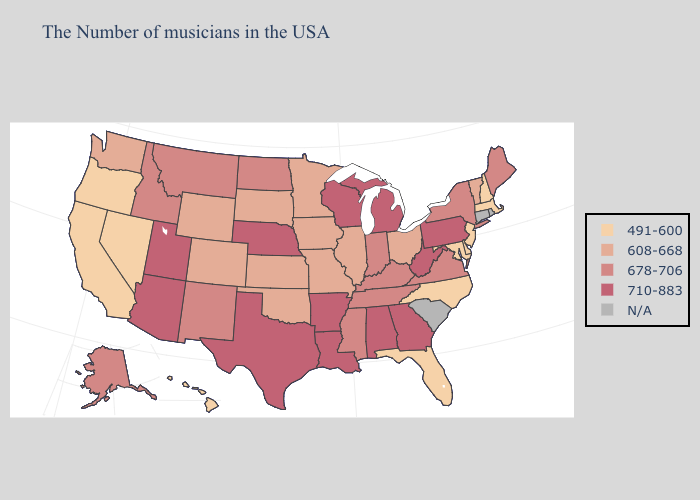How many symbols are there in the legend?
Concise answer only. 5. Which states have the lowest value in the South?
Be succinct. Delaware, Maryland, North Carolina, Florida. What is the highest value in states that border Mississippi?
Write a very short answer. 710-883. Among the states that border Kansas , does Nebraska have the lowest value?
Be succinct. No. Which states hav the highest value in the South?
Quick response, please. West Virginia, Georgia, Alabama, Louisiana, Arkansas, Texas. Among the states that border South Carolina , does North Carolina have the highest value?
Write a very short answer. No. What is the value of New Mexico?
Concise answer only. 678-706. What is the lowest value in the USA?
Keep it brief. 491-600. Does Missouri have the highest value in the MidWest?
Keep it brief. No. What is the highest value in the USA?
Be succinct. 710-883. Which states have the lowest value in the USA?
Keep it brief. Massachusetts, New Hampshire, New Jersey, Delaware, Maryland, North Carolina, Florida, Nevada, California, Oregon, Hawaii. Name the states that have a value in the range 678-706?
Give a very brief answer. Maine, New York, Virginia, Kentucky, Indiana, Tennessee, Mississippi, North Dakota, New Mexico, Montana, Idaho, Alaska. Name the states that have a value in the range 608-668?
Write a very short answer. Vermont, Ohio, Illinois, Missouri, Minnesota, Iowa, Kansas, Oklahoma, South Dakota, Wyoming, Colorado, Washington. Is the legend a continuous bar?
Give a very brief answer. No. Name the states that have a value in the range 608-668?
Be succinct. Vermont, Ohio, Illinois, Missouri, Minnesota, Iowa, Kansas, Oklahoma, South Dakota, Wyoming, Colorado, Washington. 